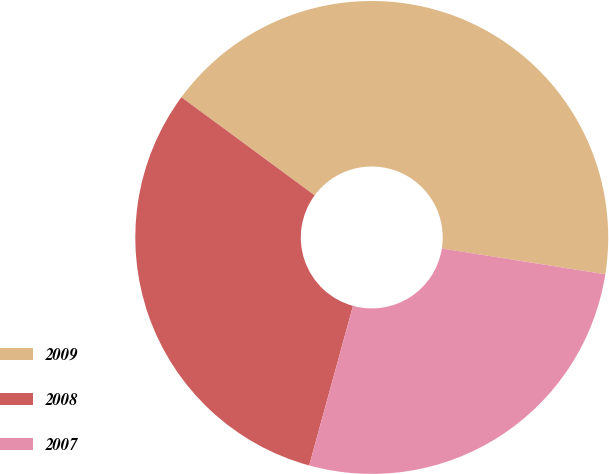Convert chart. <chart><loc_0><loc_0><loc_500><loc_500><pie_chart><fcel>2009<fcel>2008<fcel>2007<nl><fcel>42.38%<fcel>30.84%<fcel>26.77%<nl></chart> 